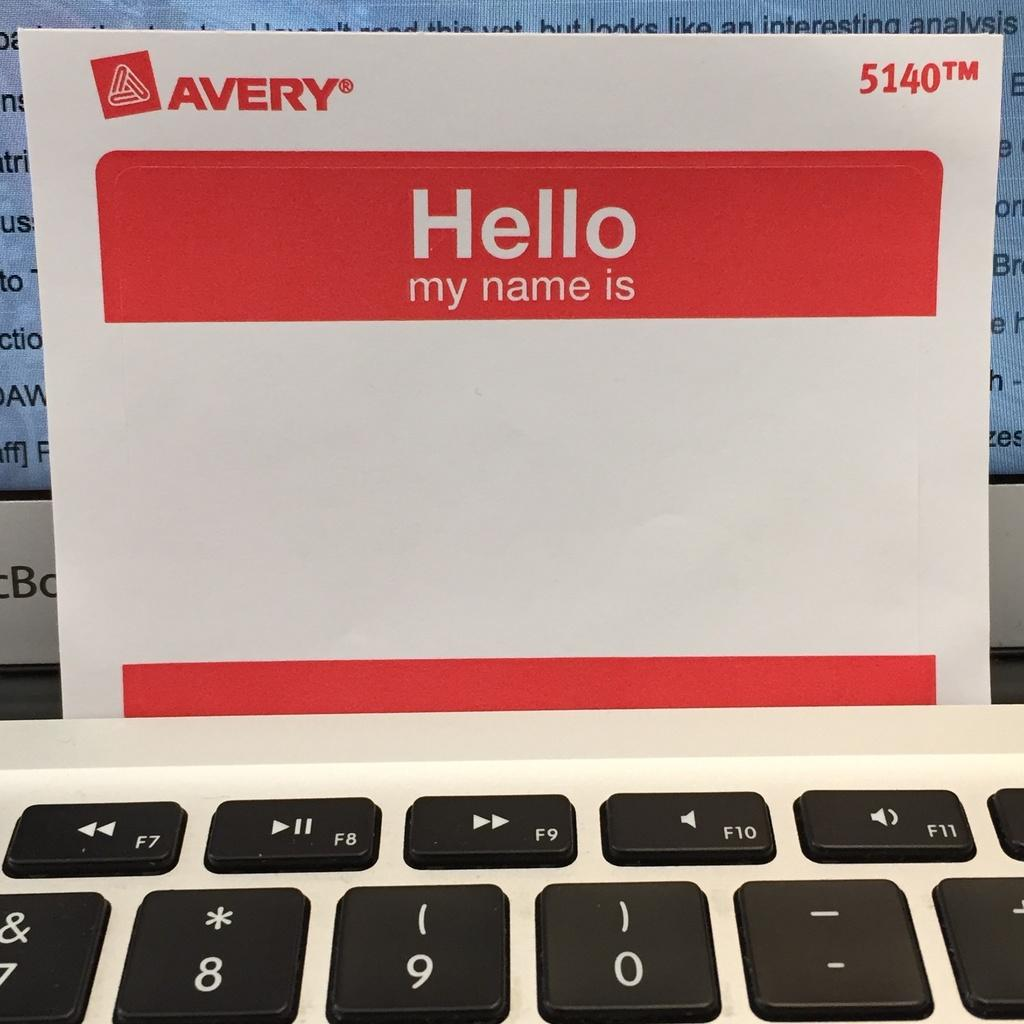Provide a one-sentence caption for the provided image. A blank avery sticky back name tag with red borders. 